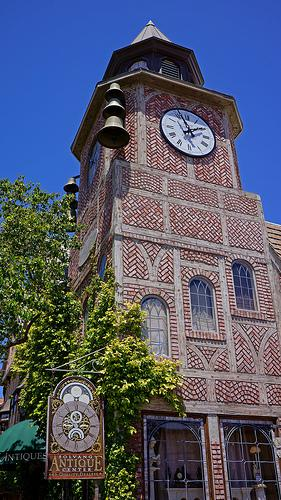Question: where was this photo taken?
Choices:
A. In front of the Trump tower.
B. In front of the clock tower.
C. Close to the casino.
D. Close to the strip.
Answer with the letter. Answer: B Question: what is present?
Choices:
A. A man.
B. A building.
C. A car.
D. A bus.
Answer with the letter. Answer: B Question: how is the photo?
Choices:
A. Fuzzy.
B. Clear.
C. Blurry.
D. Overexposed.
Answer with the letter. Answer: B Question: what else is visible?
Choices:
A. Flowers.
B. Trees.
C. Weeds.
D. Cows.
Answer with the letter. Answer: B Question: who is present?
Choices:
A. Nobody.
B. A man.
C. A woman.
D. A child.
Answer with the letter. Answer: A 